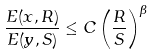Convert formula to latex. <formula><loc_0><loc_0><loc_500><loc_500>\frac { E ( x , R ) } { E ( y , S ) } \leq C \left ( \frac { R } { S } \right ) ^ { \beta }</formula> 